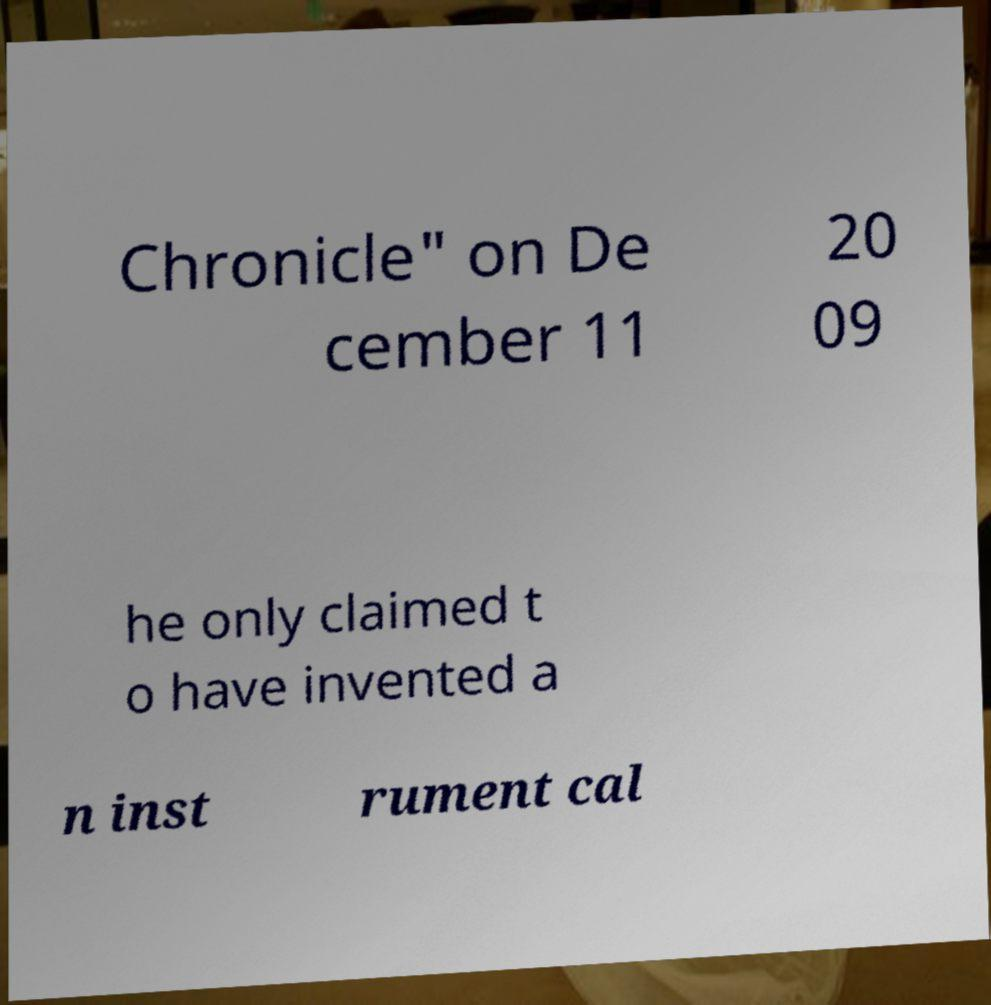Could you assist in decoding the text presented in this image and type it out clearly? Chronicle" on De cember 11 20 09 he only claimed t o have invented a n inst rument cal 